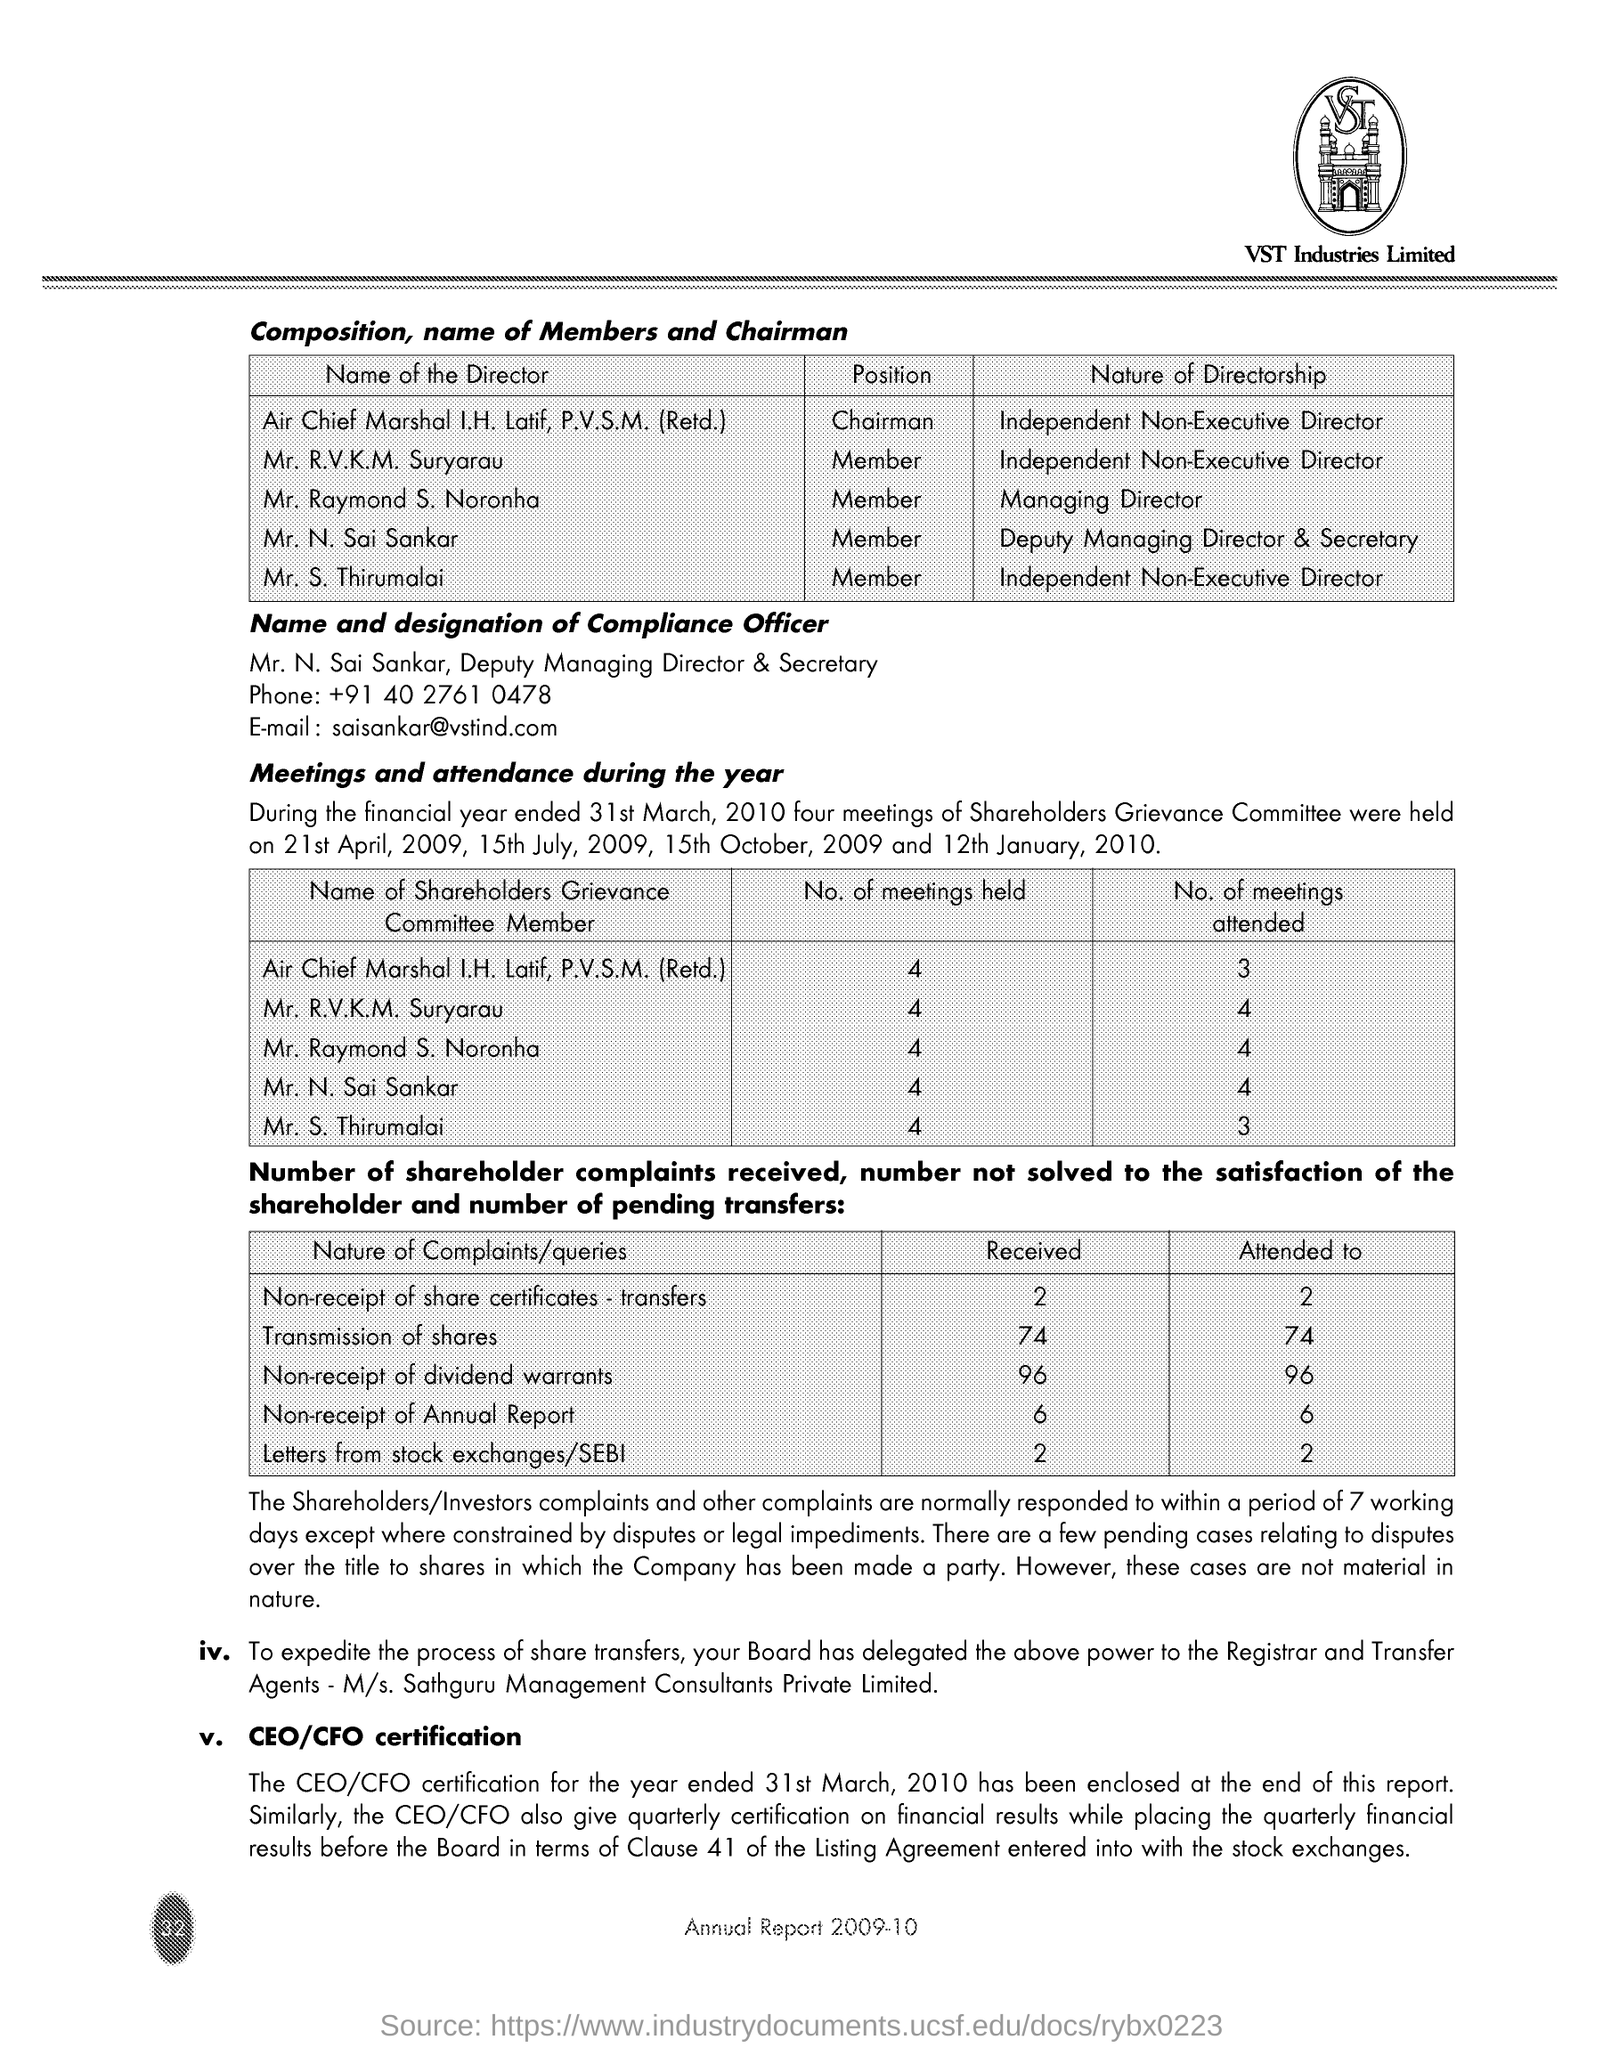Highlight a few significant elements in this photo. During the financial year ended March 31, 2010, Mr. N. Sai Sankar attended four meetings of the Shareholders Grievance Committee. Mr. Raymond S. Noronha holds the position of Managing Director, which is the nature of his directorship. The compliance officer's name is Mr. N. Sai Sankar. Mr. S. Thirumalai attended three Shareholders Grievance Committe Meetings during the financial year ended 31st March, 2010. During the year 2023, six complaints were received from shareholders regarding the non-receipt of the annual report. 